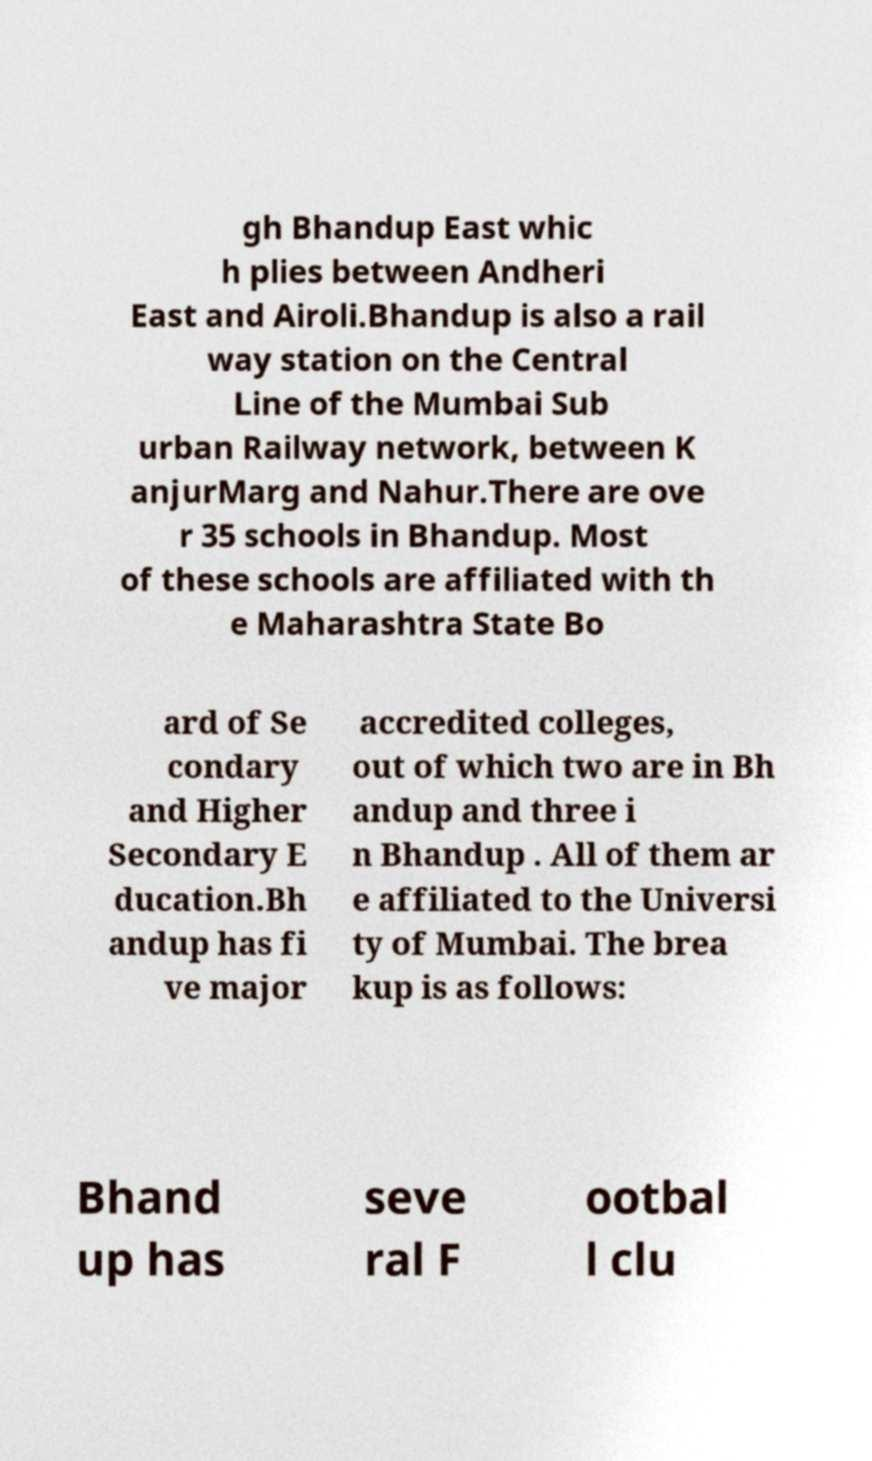I need the written content from this picture converted into text. Can you do that? gh Bhandup East whic h plies between Andheri East and Airoli.Bhandup is also a rail way station on the Central Line of the Mumbai Sub urban Railway network, between K anjurMarg and Nahur.There are ove r 35 schools in Bhandup. Most of these schools are affiliated with th e Maharashtra State Bo ard of Se condary and Higher Secondary E ducation.Bh andup has fi ve major accredited colleges, out of which two are in Bh andup and three i n Bhandup . All of them ar e affiliated to the Universi ty of Mumbai. The brea kup is as follows: Bhand up has seve ral F ootbal l clu 